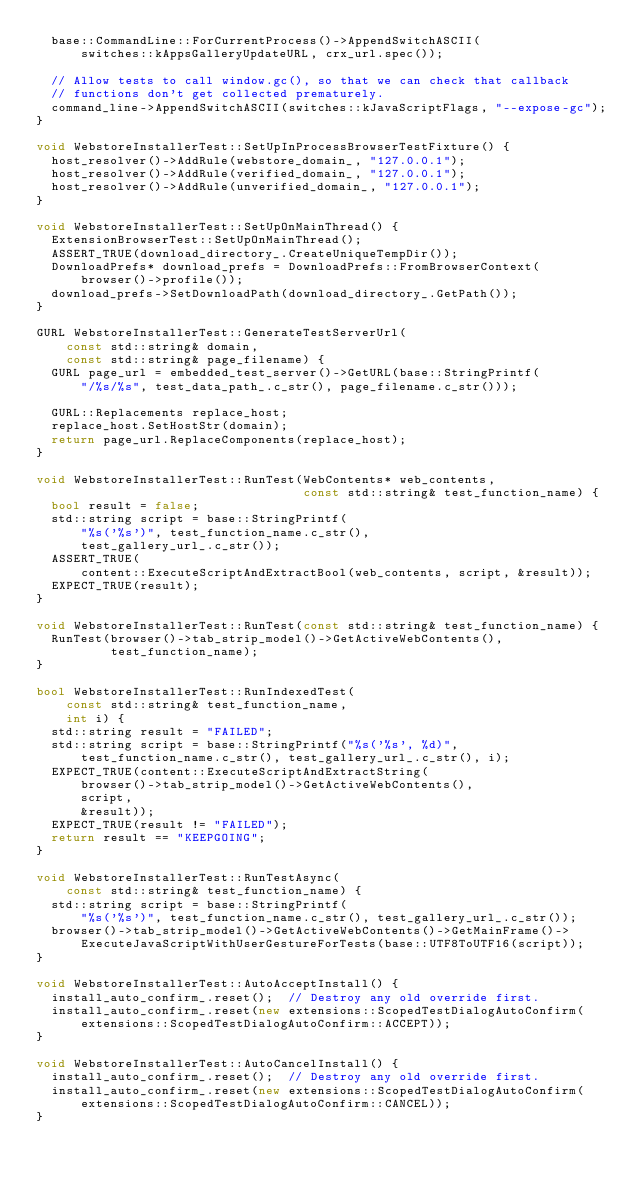<code> <loc_0><loc_0><loc_500><loc_500><_C++_>  base::CommandLine::ForCurrentProcess()->AppendSwitchASCII(
      switches::kAppsGalleryUpdateURL, crx_url.spec());

  // Allow tests to call window.gc(), so that we can check that callback
  // functions don't get collected prematurely.
  command_line->AppendSwitchASCII(switches::kJavaScriptFlags, "--expose-gc");
}

void WebstoreInstallerTest::SetUpInProcessBrowserTestFixture() {
  host_resolver()->AddRule(webstore_domain_, "127.0.0.1");
  host_resolver()->AddRule(verified_domain_, "127.0.0.1");
  host_resolver()->AddRule(unverified_domain_, "127.0.0.1");
}

void WebstoreInstallerTest::SetUpOnMainThread() {
  ExtensionBrowserTest::SetUpOnMainThread();
  ASSERT_TRUE(download_directory_.CreateUniqueTempDir());
  DownloadPrefs* download_prefs = DownloadPrefs::FromBrowserContext(
      browser()->profile());
  download_prefs->SetDownloadPath(download_directory_.GetPath());
}

GURL WebstoreInstallerTest::GenerateTestServerUrl(
    const std::string& domain,
    const std::string& page_filename) {
  GURL page_url = embedded_test_server()->GetURL(base::StringPrintf(
      "/%s/%s", test_data_path_.c_str(), page_filename.c_str()));

  GURL::Replacements replace_host;
  replace_host.SetHostStr(domain);
  return page_url.ReplaceComponents(replace_host);
}

void WebstoreInstallerTest::RunTest(WebContents* web_contents,
                                    const std::string& test_function_name) {
  bool result = false;
  std::string script = base::StringPrintf(
      "%s('%s')", test_function_name.c_str(),
      test_gallery_url_.c_str());
  ASSERT_TRUE(
      content::ExecuteScriptAndExtractBool(web_contents, script, &result));
  EXPECT_TRUE(result);
}

void WebstoreInstallerTest::RunTest(const std::string& test_function_name) {
  RunTest(browser()->tab_strip_model()->GetActiveWebContents(),
          test_function_name);
}

bool WebstoreInstallerTest::RunIndexedTest(
    const std::string& test_function_name,
    int i) {
  std::string result = "FAILED";
  std::string script = base::StringPrintf("%s('%s', %d)",
      test_function_name.c_str(), test_gallery_url_.c_str(), i);
  EXPECT_TRUE(content::ExecuteScriptAndExtractString(
      browser()->tab_strip_model()->GetActiveWebContents(),
      script,
      &result));
  EXPECT_TRUE(result != "FAILED");
  return result == "KEEPGOING";
}

void WebstoreInstallerTest::RunTestAsync(
    const std::string& test_function_name) {
  std::string script = base::StringPrintf(
      "%s('%s')", test_function_name.c_str(), test_gallery_url_.c_str());
  browser()->tab_strip_model()->GetActiveWebContents()->GetMainFrame()->
      ExecuteJavaScriptWithUserGestureForTests(base::UTF8ToUTF16(script));
}

void WebstoreInstallerTest::AutoAcceptInstall() {
  install_auto_confirm_.reset();  // Destroy any old override first.
  install_auto_confirm_.reset(new extensions::ScopedTestDialogAutoConfirm(
      extensions::ScopedTestDialogAutoConfirm::ACCEPT));
}

void WebstoreInstallerTest::AutoCancelInstall() {
  install_auto_confirm_.reset();  // Destroy any old override first.
  install_auto_confirm_.reset(new extensions::ScopedTestDialogAutoConfirm(
      extensions::ScopedTestDialogAutoConfirm::CANCEL));
}
</code> 